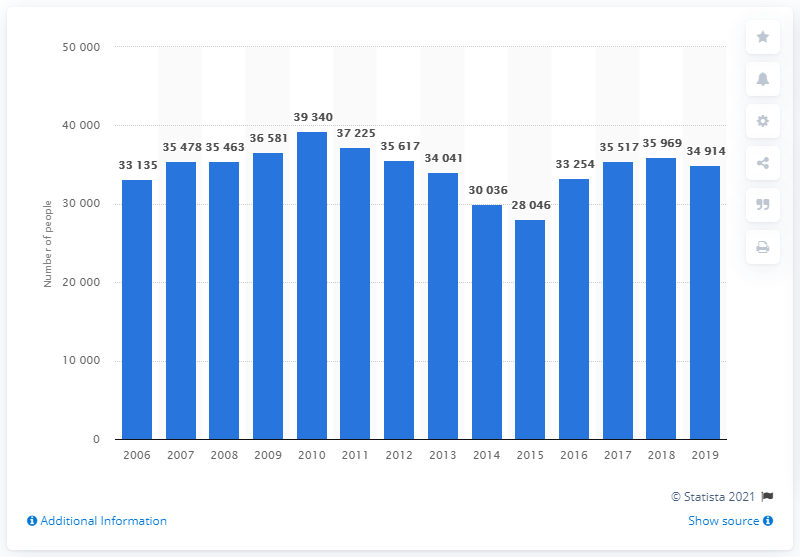Specify some key components in this picture. During the period of 2006 to 2010, a total of 39,340 individuals were reported for drug offenses. In 2019, there were 3,4914 reported cases of drug offenses in Italy. 